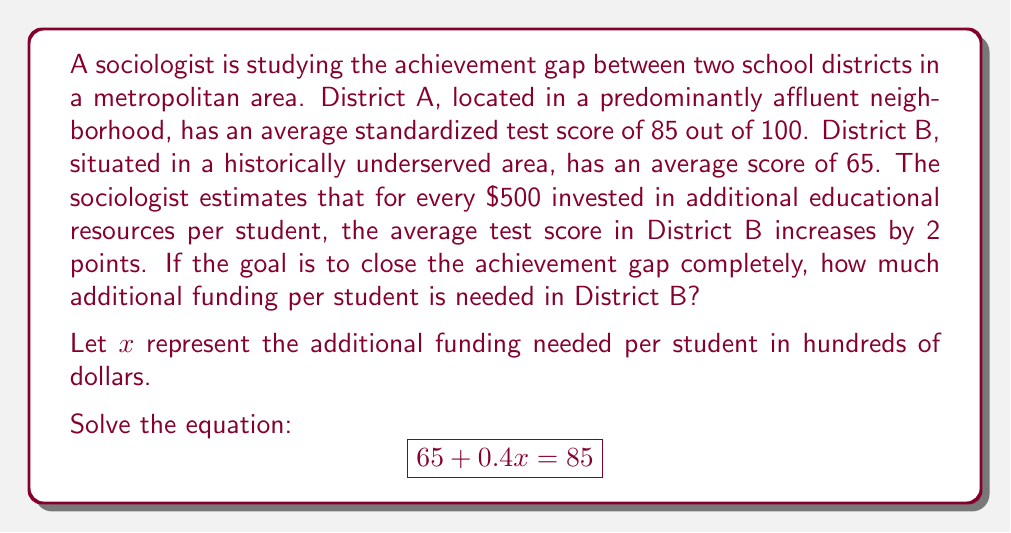Help me with this question. To solve this problem, we'll follow these steps:

1) Let's start with our equation:
   $$65 + 0.4x = 85$$

2) Subtract 65 from both sides to isolate the term with $x$:
   $$0.4x = 20$$

3) Divide both sides by 0.4 to solve for $x$:
   $$x = \frac{20}{0.4} = 50$$

4) Interpret the result:
   $x = 50$ means 50 hundred dollars, which is $5,000.

5) Check our answer:
   If we invest $5,000 per student, the score should increase by:
   $\frac{5000}{500} \times 2 = 20$ points

   Indeed, $65 + 20 = 85$, which matches District A's score.

This solution highlights the significant investment needed to close achievement gaps, underscoring the impact of systemic inequalities in education funding and resources.
Answer: $5,000 per student 